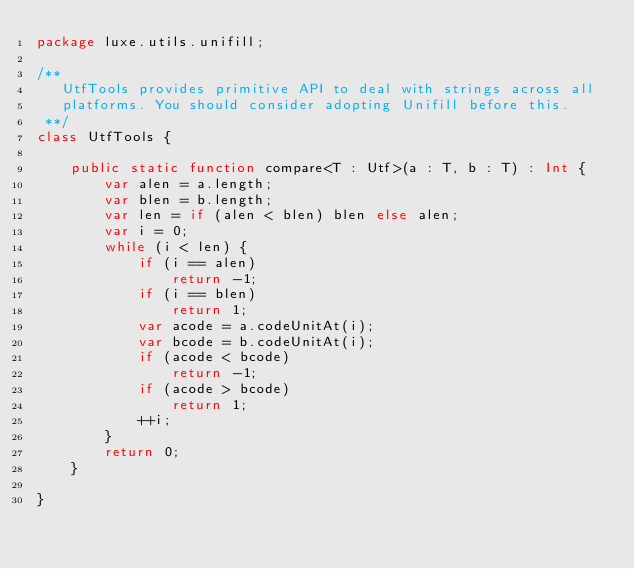Convert code to text. <code><loc_0><loc_0><loc_500><loc_500><_Haxe_>package luxe.utils.unifill;

/**
   UtfTools provides primitive API to deal with strings across all
   platforms. You should consider adopting Unifill before this.
 **/
class UtfTools {

    public static function compare<T : Utf>(a : T, b : T) : Int {
        var alen = a.length;
        var blen = b.length;
        var len = if (alen < blen) blen else alen;
        var i = 0;
        while (i < len) {
            if (i == alen)
                return -1;
            if (i == blen)
                return 1;
            var acode = a.codeUnitAt(i);
            var bcode = b.codeUnitAt(i);
            if (acode < bcode)
                return -1;
            if (acode > bcode)
                return 1;
            ++i;
        }
        return 0;
    }

}
</code> 